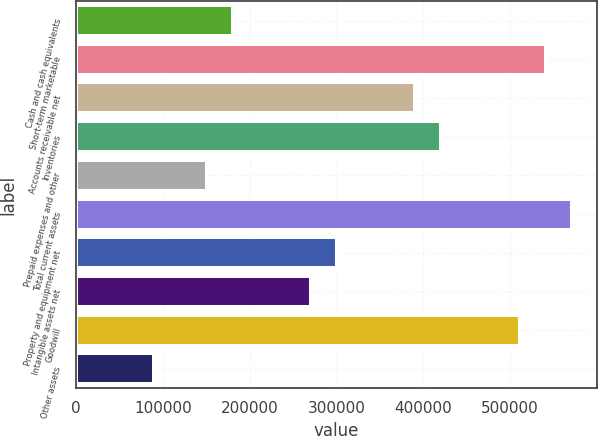Convert chart. <chart><loc_0><loc_0><loc_500><loc_500><bar_chart><fcel>Cash and cash equivalents<fcel>Short-term marketable<fcel>Accounts receivable net<fcel>Inventories<fcel>Prepaid expenses and other<fcel>Total current assets<fcel>Property and equipment net<fcel>Intangible assets net<fcel>Goodwill<fcel>Other assets<nl><fcel>180519<fcel>541324<fcel>390988<fcel>421055<fcel>150452<fcel>571391<fcel>300787<fcel>270720<fcel>511257<fcel>90317.3<nl></chart> 